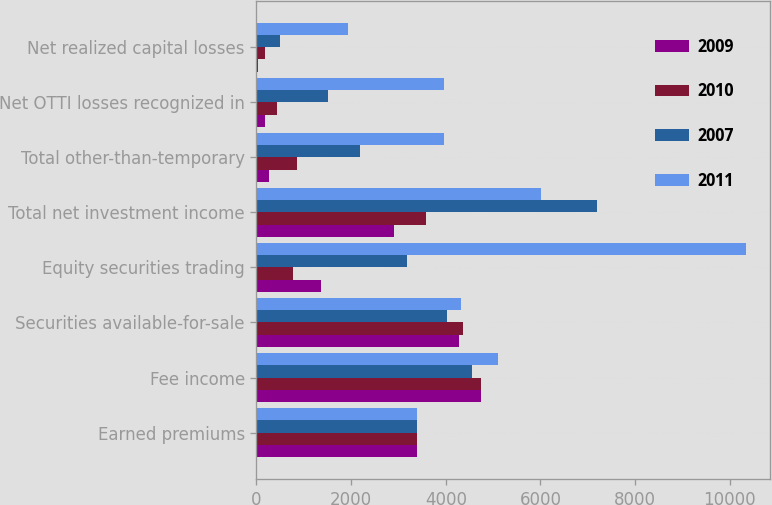Convert chart to OTSL. <chart><loc_0><loc_0><loc_500><loc_500><stacked_bar_chart><ecel><fcel>Earned premiums<fcel>Fee income<fcel>Securities available-for-sale<fcel>Equity securities trading<fcel>Total net investment income<fcel>Total other-than-temporary<fcel>Net OTTI losses recognized in<fcel>Net realized capital losses<nl><fcel>2009<fcel>3389<fcel>4750<fcel>4272<fcel>1359<fcel>2913<fcel>263<fcel>174<fcel>29<nl><fcel>2010<fcel>3389<fcel>4748<fcel>4364<fcel>774<fcel>3590<fcel>852<fcel>434<fcel>177<nl><fcel>2007<fcel>3389<fcel>4547<fcel>4017<fcel>3188<fcel>7205<fcel>2191<fcel>1508<fcel>496<nl><fcel>2011<fcel>3389<fcel>5103<fcel>4327<fcel>10340<fcel>6013<fcel>3964<fcel>3964<fcel>1941<nl></chart> 